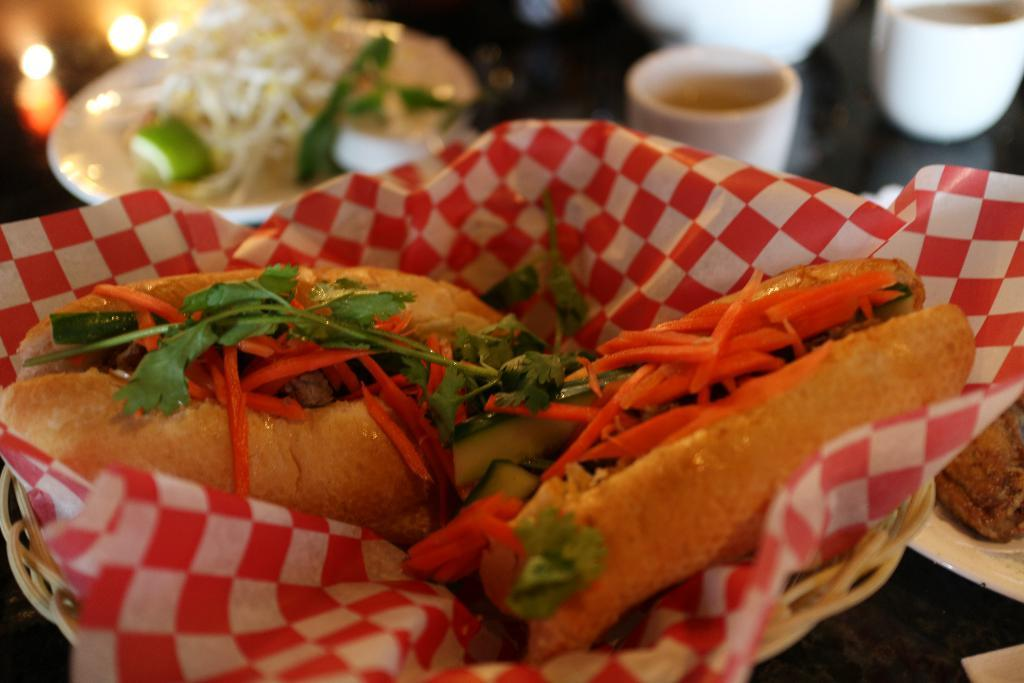What is placed on the platform in the image? There is food on the platform. How is the food protected or covered? There is a cover on the platform. What type of dishware is present on the platform? There are plates and cups on the platform. What can be seen in the background of the image? There are lights visible in the background. What type of tent is visible in the image? There is no tent present in the image. What religious symbol can be seen on the platform? There is no religious symbol present in the image. 